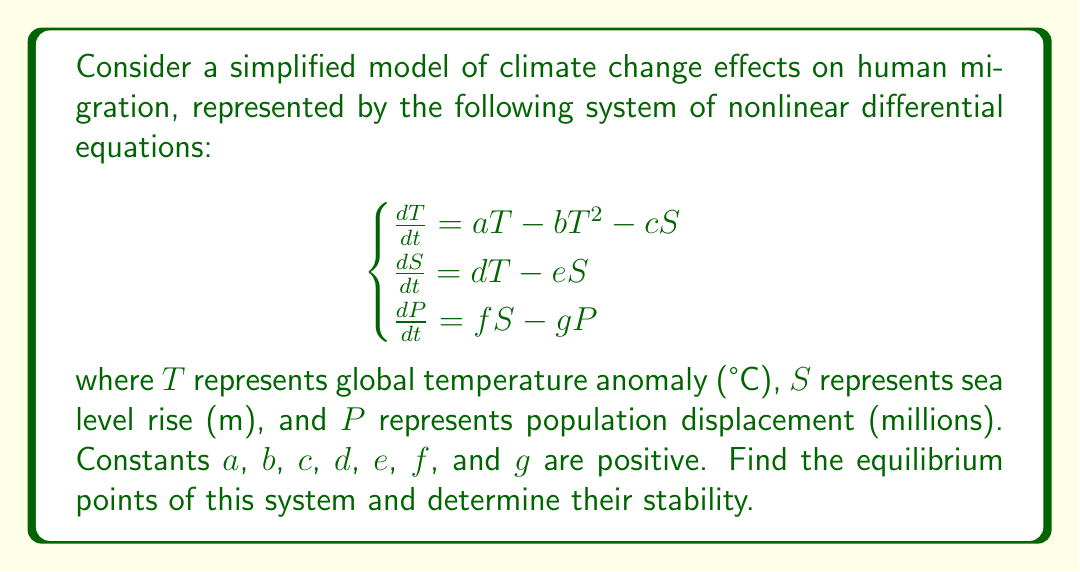Can you solve this math problem? To solve this problem, we'll follow these steps:

1) Find the equilibrium points by setting all derivatives to zero:

$$\begin{cases}
aT - bT^2 - cS = 0 \\
dT - eS = 0 \\
fS - gP = 0
\end{cases}$$

2) From the second equation: $S = \frac{d}{e}T$

3) Substitute this into the first equation:

$$aT - bT^2 - c\frac{d}{e}T = 0$$
$$T(a - bT - \frac{cd}{e}) = 0$$

4) This gives us two possible solutions for T:
   $T = 0$ or $T = \frac{ae - cd}{be}$

5) If $T = 0$, then $S = 0$ and $P = 0$. This is our first equilibrium point: $(0, 0, 0)$.

6) For the second solution:
   $T = \frac{ae - cd}{be}$
   $S = \frac{d}{e}T = \frac{d(ae - cd)}{be^2}$
   $P = \frac{f}{g}S = \frac{fd(ae - cd)}{gbe^2}$

7) To determine stability, we need to calculate the Jacobian matrix at each equilibrium point:

$$J = \begin{bmatrix}
a - 2bT - c & -c & 0 \\
d & -e & 0 \\
0 & f & -g
\end{bmatrix}$$

8) At $(0, 0, 0)$:

$$J_{(0,0,0)} = \begin{bmatrix}
a & -c & 0 \\
d & -e & 0 \\
0 & f & -g
\end{bmatrix}$$

The eigenvalues are $a$, $-e$, and $-g$. Since $a > 0$, this point is unstable.

9) At the second equilibrium point:

$$J_{(T,S,P)} = \begin{bmatrix}
-a & -c & 0 \\
d & -e & 0 \\
0 & f & -g
\end{bmatrix}$$

All eigenvalues have negative real parts, so this point is stable.
Answer: Two equilibrium points: $(0, 0, 0)$ (unstable) and $(\frac{ae - cd}{be}, \frac{d(ae - cd)}{be^2}, \frac{fd(ae - cd)}{gbe^2})$ (stable). 